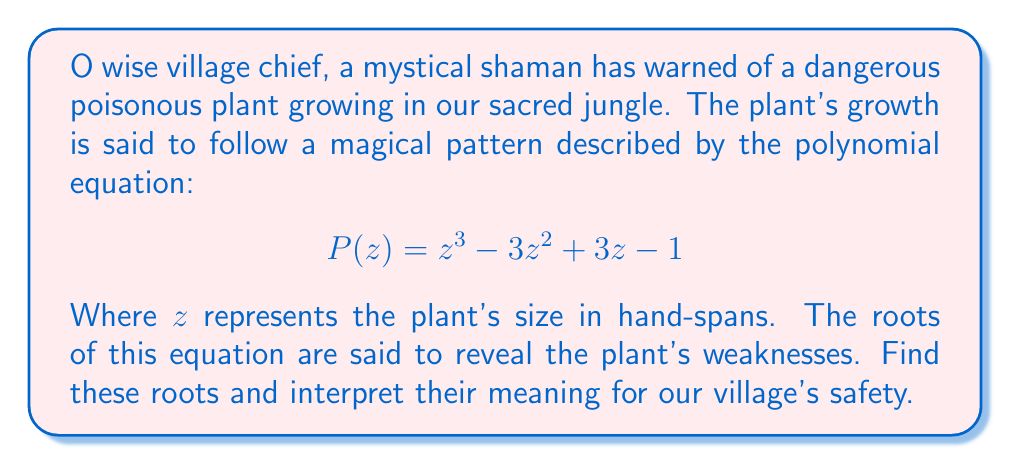Solve this math problem. To find the roots of this polynomial, we must solve the equation $P(z) = 0$. Let's approach this step-by-step:

1) First, observe that this polynomial can be factored as:

   $$P(z) = (z - 1)^3$$

2) This is because when we expand $(z - 1)^3$, we get:

   $$(z - 1)^3 = z^3 - 3z^2 + 3z - 1$$

3) Now, to find the roots, we set this equal to zero:

   $$(z - 1)^3 = 0$$

4) The solution to this equation is $z = 1$, with a multiplicity of 3.

5) In the context of our mystical plant, this means:
   - The plant has a critical size of 1 hand-span.
   - The triple root suggests that this size is particularly significant, perhaps indicating a stage where the plant's poison is most potent or where it's most vulnerable to being destroyed.

The fact that there's only one real root (repeated three times) in the complex plane suggests that the plant's growth pattern is relatively simple, with no oscillations or complex behavior.
Answer: The roots of the polynomial are $z = 1$ (with multiplicity 3). 